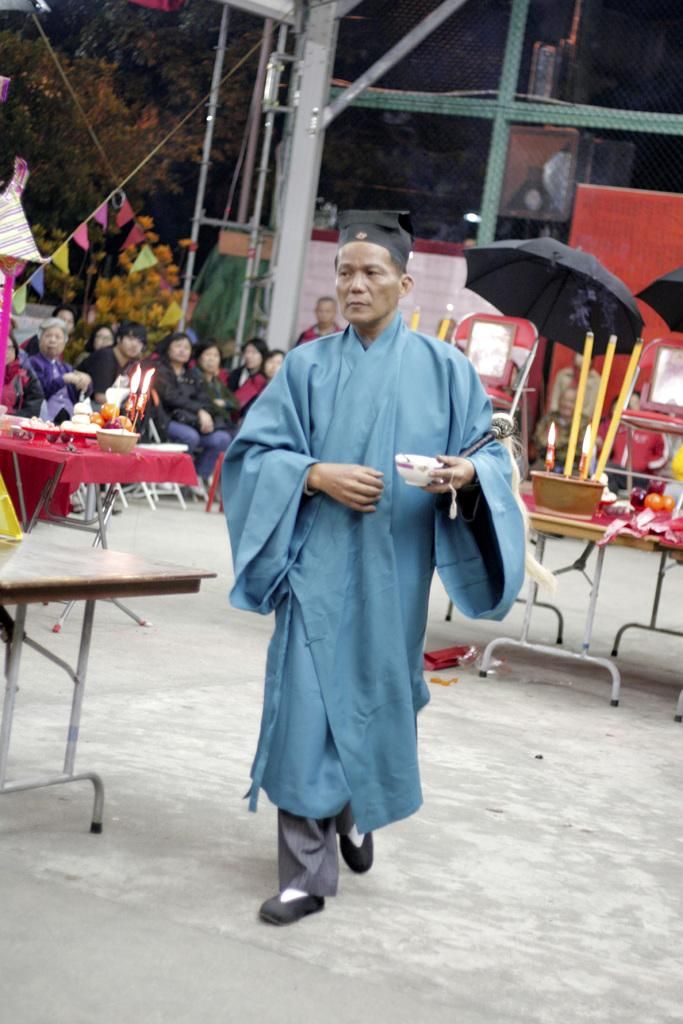What type of vegetation can be seen in the image? There are trees in the image. Who or what is present in the image besides the trees? There are people and an umbrella in the image. What is the purpose of the umbrella in the image? The umbrella may be used for shade or protection from the elements. What is on the table in the image? There is a candle, a bowl, and plates on the table. What type of flowers are being used as a form of punishment in the image? There are no flowers or any form of punishment present in the image. 